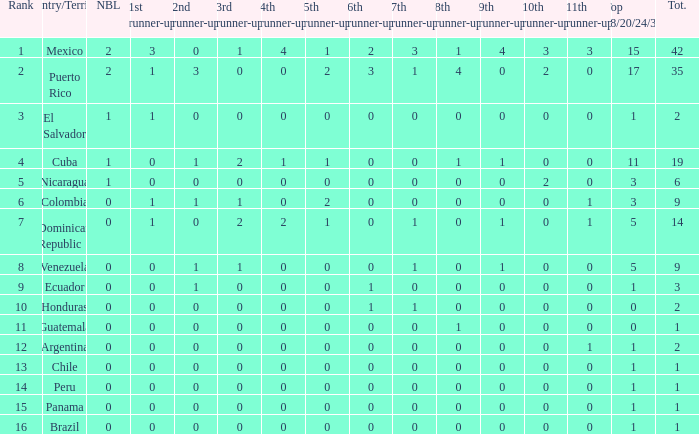What is the lowest 7th runner-up of the country with a top 18/20/24/30 greater than 5, a 1st runner-up greater than 0, and an 11th runner-up less than 0? None. Can you parse all the data within this table? {'header': ['Rank', 'Country/Territory', 'NBL', '1st runner-up', '2nd runner-up', '3rd runner-up', '4th runner-up', '5th runner-up', '6th runner-up', '7th runner-up', '8th runner-up', '9th runner-up', '10th runner-up', '11th runner-up', 'Top 18/20/24/30', 'Tot.'], 'rows': [['1', 'Mexico', '2', '3', '0', '1', '4', '1', '2', '3', '1', '4', '3', '3', '15', '42'], ['2', 'Puerto Rico', '2', '1', '3', '0', '0', '2', '3', '1', '4', '0', '2', '0', '17', '35'], ['3', 'El Salvador', '1', '1', '0', '0', '0', '0', '0', '0', '0', '0', '0', '0', '1', '2'], ['4', 'Cuba', '1', '0', '1', '2', '1', '1', '0', '0', '1', '1', '0', '0', '11', '19'], ['5', 'Nicaragua', '1', '0', '0', '0', '0', '0', '0', '0', '0', '0', '2', '0', '3', '6'], ['6', 'Colombia', '0', '1', '1', '1', '0', '2', '0', '0', '0', '0', '0', '1', '3', '9'], ['7', 'Dominican Republic', '0', '1', '0', '2', '2', '1', '0', '1', '0', '1', '0', '1', '5', '14'], ['8', 'Venezuela', '0', '0', '1', '1', '0', '0', '0', '1', '0', '1', '0', '0', '5', '9'], ['9', 'Ecuador', '0', '0', '1', '0', '0', '0', '1', '0', '0', '0', '0', '0', '1', '3'], ['10', 'Honduras', '0', '0', '0', '0', '0', '0', '1', '1', '0', '0', '0', '0', '0', '2'], ['11', 'Guatemala', '0', '0', '0', '0', '0', '0', '0', '0', '1', '0', '0', '0', '0', '1'], ['12', 'Argentina', '0', '0', '0', '0', '0', '0', '0', '0', '0', '0', '0', '1', '1', '2'], ['13', 'Chile', '0', '0', '0', '0', '0', '0', '0', '0', '0', '0', '0', '0', '1', '1'], ['14', 'Peru', '0', '0', '0', '0', '0', '0', '0', '0', '0', '0', '0', '0', '1', '1'], ['15', 'Panama', '0', '0', '0', '0', '0', '0', '0', '0', '0', '0', '0', '0', '1', '1'], ['16', 'Brazil', '0', '0', '0', '0', '0', '0', '0', '0', '0', '0', '0', '0', '1', '1']]} 